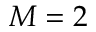<formula> <loc_0><loc_0><loc_500><loc_500>M = 2</formula> 